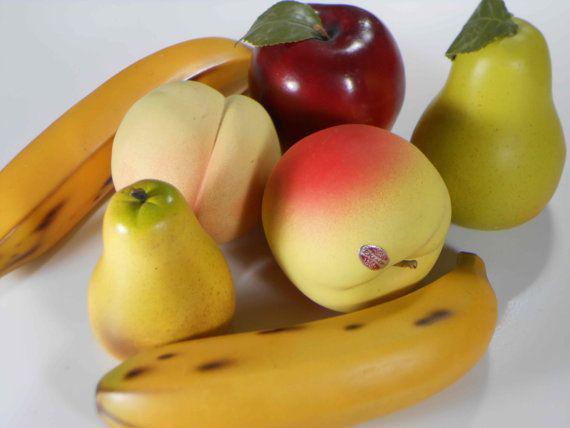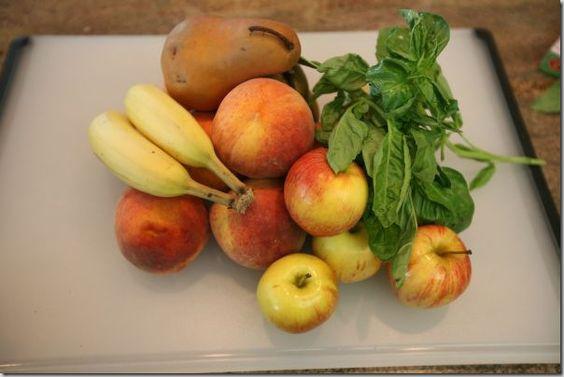The first image is the image on the left, the second image is the image on the right. Analyze the images presented: Is the assertion "There are entirely green apples among the fruit in the right image." valid? Answer yes or no. No. The first image is the image on the left, the second image is the image on the right. Assess this claim about the two images: "An image shows fruit that is not in a container and includes at least one yellow banana and yellow-green pear.". Correct or not? Answer yes or no. Yes. 